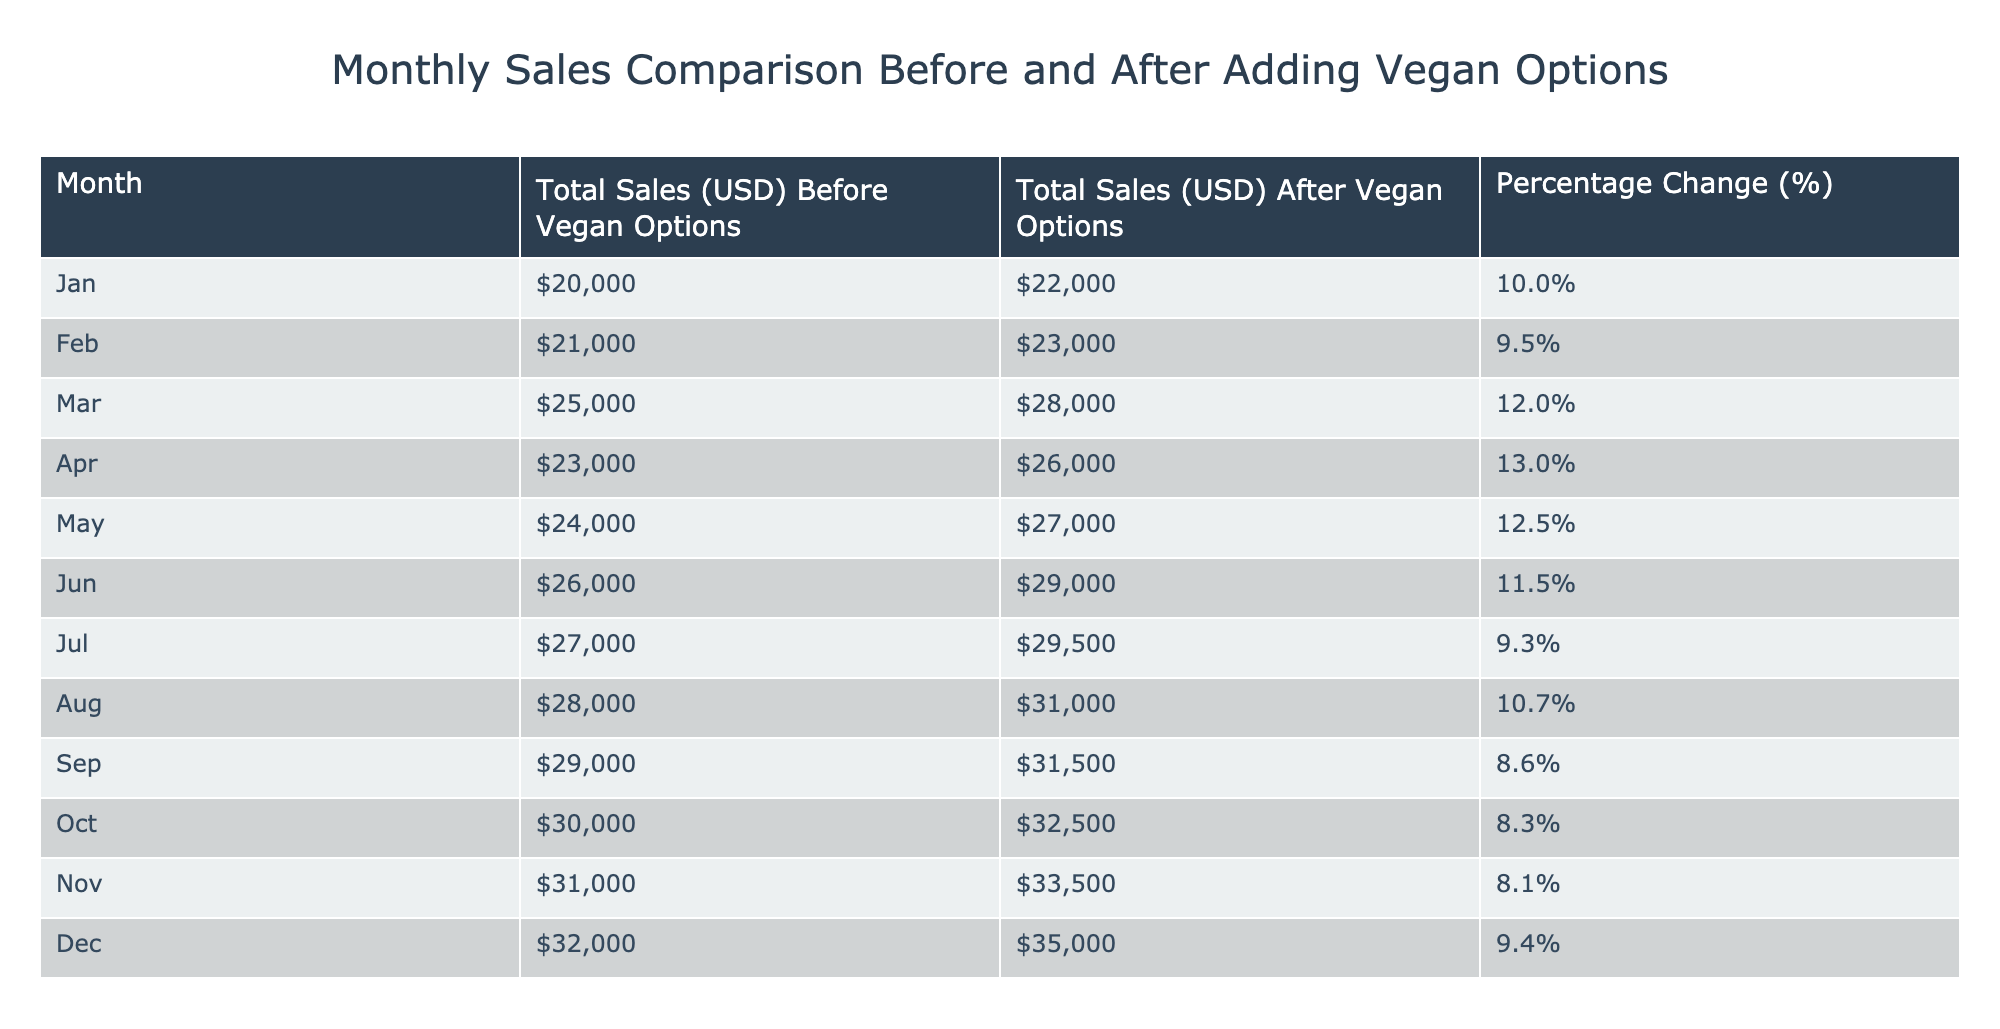What was the total sales in January before adding vegan options? The table shows that the total sales in January before adding vegan options was 20000 USD.
Answer: 20000 What is the percentage change in total sales from February before to after adding vegan options? The percentage change in February is provided in the table as 9.5%.
Answer: 9.5% What was the total sales after adding vegan options in July? According to the table, the total sales in July after adding vegan options was 29500 USD.
Answer: 29500 Which month had the highest percentage change in sales after adding vegan options? The table indicates that March had the highest percentage change at 12.0%.
Answer: March What was the total sales difference between December and January after adding vegan options? After adding vegan options, December's sales were 35000 and January's were 22000. The difference is 35000 - 22000 = 13000.
Answer: 13000 Was there a percentage change greater than 10% in any month after adding vegan options? Yes, the table shows that March (12.0%), April (13.0%), and May (12.5%) all had percentage changes greater than 10%.
Answer: Yes What is the average total sales before adding vegan options over the 12 months? The total sales before adding vegan options are: 20000, 21000, 25000, 23000, 24000, 26000, 27000, 28000, 29000, 30000, 31000, 32000. The sum is 310000, and dividing by 12 gives an average of 25833.33, rounded to 25833.
Answer: 25833 In which month were sales after adding vegan options lower than the total sales before? The table shows that there were no months where sales after adding vegan options were lower than before; all after values are higher.
Answer: No What months experienced less than 10% increase in sales after adding vegan options? Looking at the table, the months July (9.3%), September (8.6%), October (8.3%), and November (8.1%) all experienced less than a 10% increase.
Answer: July, September, October, November What total sales increase was observed from August to September after adding vegan options? The sales in August after vegan options were 31000, and in September, it was 31500. Thus, the increase is 31500 - 31000 = 500.
Answer: 500 